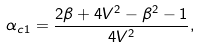Convert formula to latex. <formula><loc_0><loc_0><loc_500><loc_500>\alpha _ { c 1 } = \frac { 2 \beta + 4 V ^ { 2 } - \beta ^ { 2 } - 1 } { 4 V ^ { 2 } } ,</formula> 